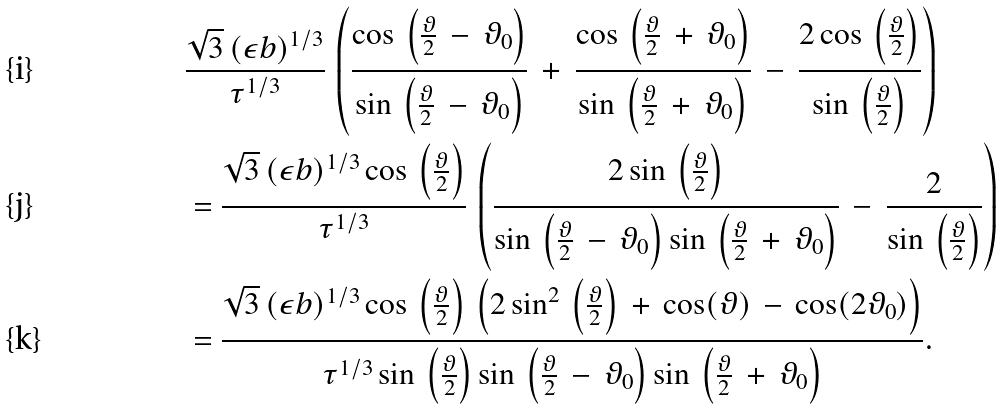Convert formula to latex. <formula><loc_0><loc_0><loc_500><loc_500>& \frac { \sqrt { 3 } \, ( \epsilon b ) ^ { 1 / 3 } } { \tau ^ { 1 / 3 } } \, \left ( \frac { \cos \, \left ( \frac { \vartheta } { 2 } \, - \, \vartheta _ { 0 } \right ) } { \sin \, \left ( \frac { \vartheta } { 2 } \, - \, \vartheta _ { 0 } \right ) } \, + \, \frac { \cos \, \left ( \frac { \vartheta } { 2 } \, + \, \vartheta _ { 0 } \right ) } { \sin \, \left ( \frac { \vartheta } { 2 } \, + \, \vartheta _ { 0 } \right ) } \, - \, \frac { 2 \cos \, \left ( \frac { \vartheta } { 2 } \right ) } { \sin \, \left ( \frac { \vartheta } { 2 } \right ) } \right ) \\ & = \frac { \sqrt { 3 } \, ( \epsilon b ) ^ { 1 / 3 } \cos \, \left ( \frac { \vartheta } { 2 } \right ) } { \tau ^ { 1 / 3 } } \, \left ( \frac { 2 \sin \, \left ( \frac { \vartheta } { 2 } \right ) } { \sin \, \left ( \frac { \vartheta } { 2 } \, - \, \vartheta _ { 0 } \right ) \sin \, \left ( \frac { \vartheta } { 2 } \, + \, \vartheta _ { 0 } \right ) } \, - \, \frac { 2 } { \sin \, \left ( \frac { \vartheta } { 2 } \right ) } \right ) \\ & = \frac { \sqrt { 3 } \, ( \epsilon b ) ^ { 1 / 3 } \cos \, \left ( \frac { \vartheta } { 2 } \right ) \, \left ( 2 \sin ^ { 2 } \, \left ( \frac { \vartheta } { 2 } \right ) \, + \, \cos ( \vartheta ) \, - \, \cos ( 2 \vartheta _ { 0 } ) \right ) } { \tau ^ { 1 / 3 } \sin \, \left ( \frac { \vartheta } { 2 } \right ) \sin \, \left ( \frac { \vartheta } { 2 } \, - \, \vartheta _ { 0 } \right ) \sin \, \left ( \frac { \vartheta } { 2 } \, + \, \vartheta _ { 0 } \right ) } .</formula> 